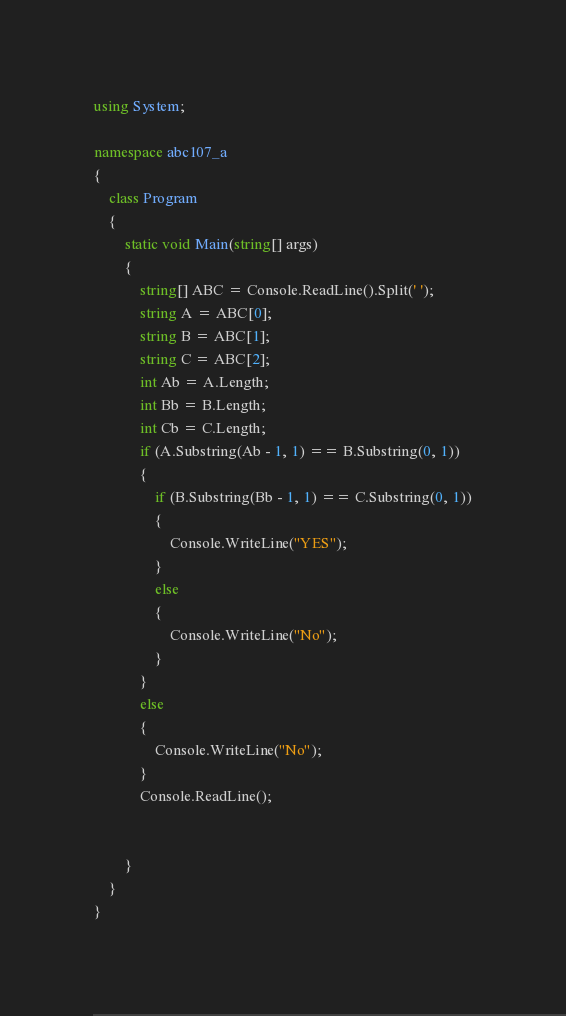<code> <loc_0><loc_0><loc_500><loc_500><_C#_>using System;

namespace abc107_a
{
    class Program
    {
        static void Main(string[] args)
        {
            string[] ABC = Console.ReadLine().Split(' ');
            string A = ABC[0];
            string B = ABC[1];
            string C = ABC[2];
            int Ab = A.Length;
            int Bb = B.Length;
            int Cb = C.Length;
            if (A.Substring(Ab - 1, 1) == B.Substring(0, 1))
            {
                if (B.Substring(Bb - 1, 1) == C.Substring(0, 1))
                {
                    Console.WriteLine("YES");
                }
                else
                {
                    Console.WriteLine("No");
                }
            }
            else
            {
                Console.WriteLine("No");
            }
            Console.ReadLine();


        }
    }
}
</code> 